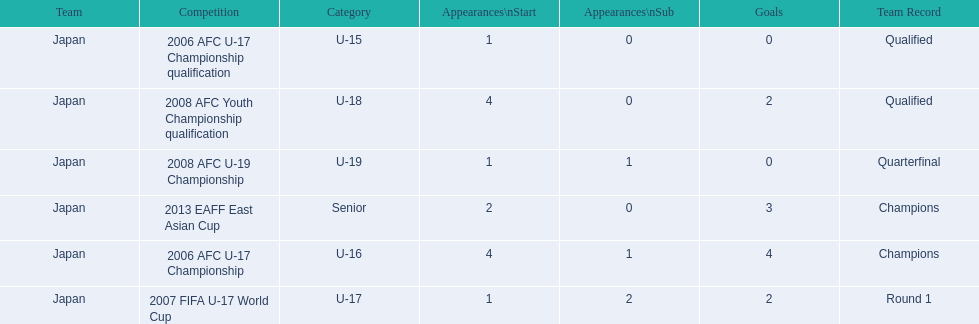How many appearances were there for each competition? 1, 4, 1, 4, 1, 2. How many goals were there for each competition? 0, 4, 2, 2, 0, 3. Which competition(s) has/have the most appearances? 2006 AFC U-17 Championship, 2008 AFC Youth Championship qualification. Which competition(s) has/have the most goals? 2006 AFC U-17 Championship. 